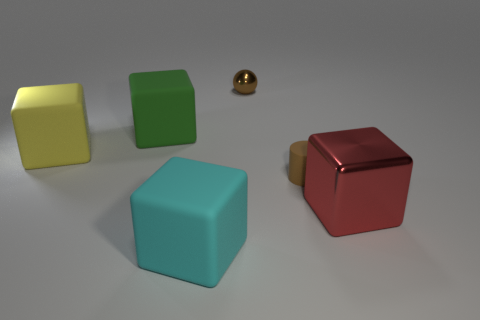There is a tiny rubber cylinder; is it the same color as the shiny thing that is behind the large yellow matte cube?
Make the answer very short. Yes. Is there a shiny block of the same size as the green rubber thing?
Offer a very short reply. Yes. There is a metallic object right of the shiny object behind the tiny brown matte object; what is its size?
Ensure brevity in your answer.  Large. Is the number of large cubes on the left side of the brown sphere less than the number of large blocks?
Make the answer very short. Yes. Is the color of the small metal ball the same as the cylinder?
Your answer should be compact. Yes. How big is the matte cylinder?
Your answer should be very brief. Small. How many small matte things are the same color as the tiny shiny thing?
Make the answer very short. 1. Is there a red thing that is in front of the shiny thing that is on the left side of the matte object that is to the right of the cyan matte object?
Offer a very short reply. Yes. There is a metal thing that is the same size as the brown matte cylinder; what shape is it?
Offer a very short reply. Sphere. What number of big things are brown matte cylinders or brown balls?
Ensure brevity in your answer.  0. 